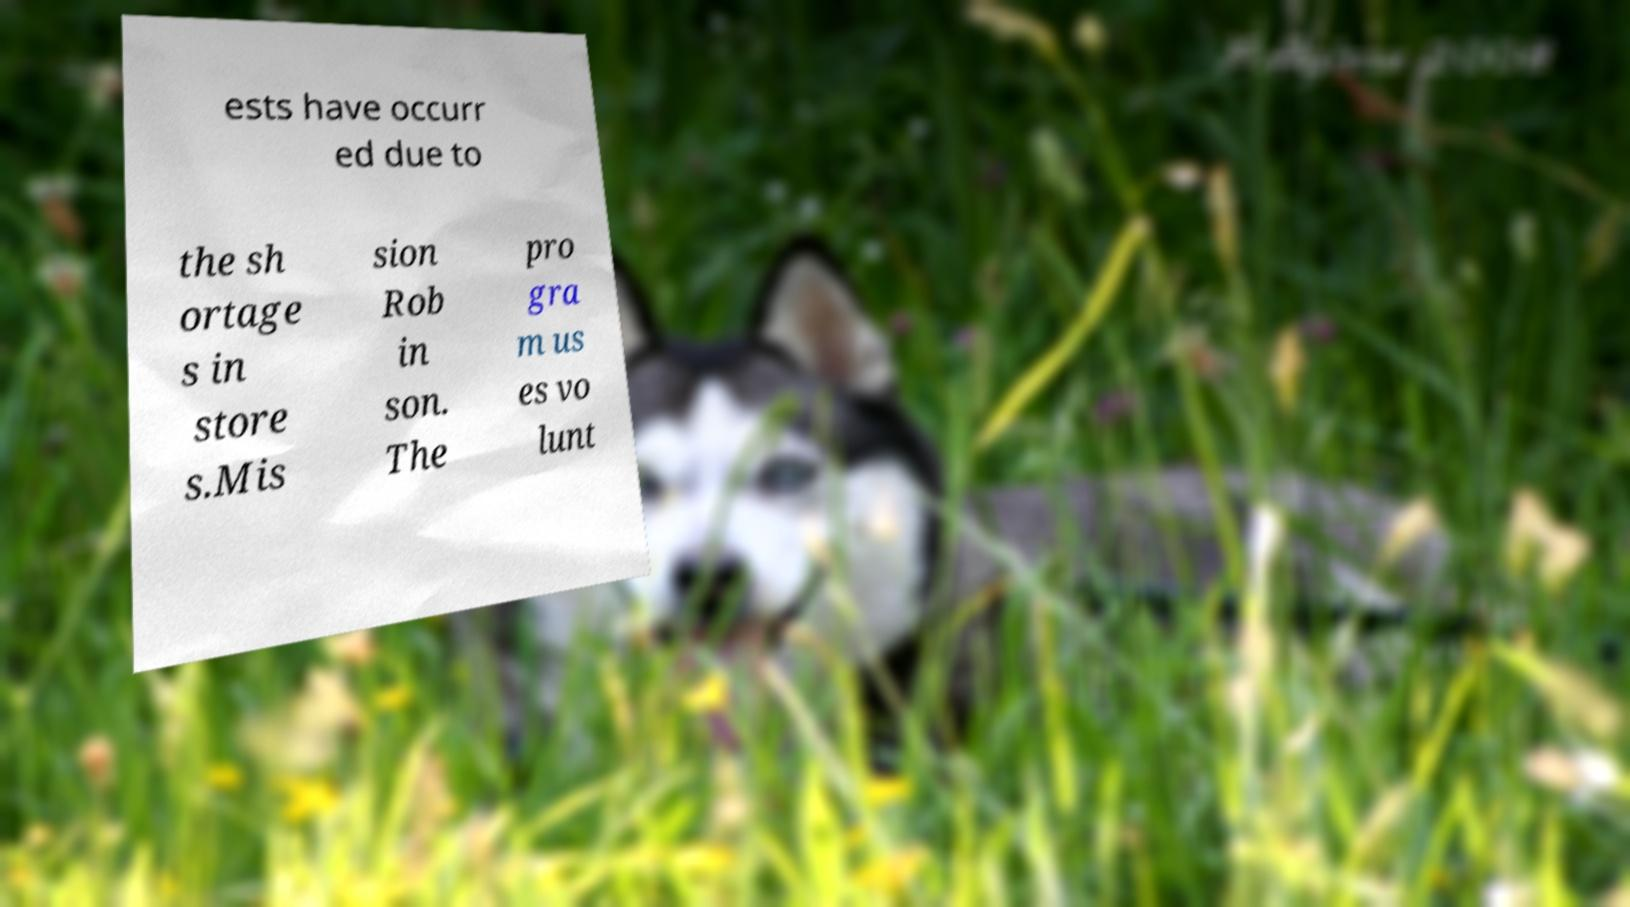What messages or text are displayed in this image? I need them in a readable, typed format. ests have occurr ed due to the sh ortage s in store s.Mis sion Rob in son. The pro gra m us es vo lunt 